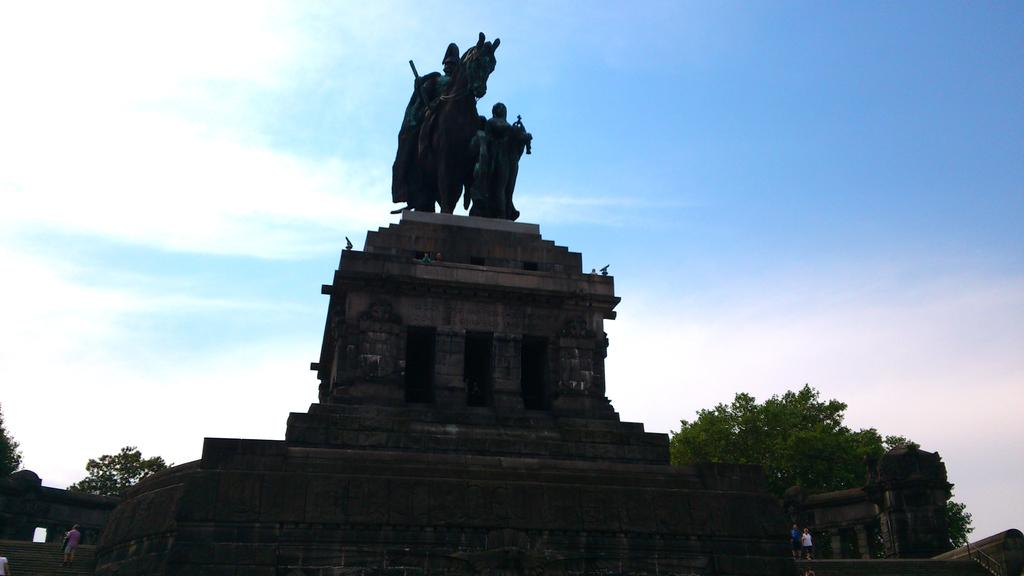What can be seen in the image that represents artistic creations? There are statues in the image. What supports the statues in the image? There is a pedestal at the bottom of the statues. What can be seen in the background of the image? There are trees and the sky visible in the background of the image. Who or what is present in the image? There are people in the image. What architectural feature is located on the left side of the image? There are stairs on the left side of the image. What is the name of the pipe that the statue is holding in the image? There is no pipe present in the image, and the statues are not holding any objects. What type of blade can be seen on the statue's arm in the image? There is no blade present on any of the statues in the image. 